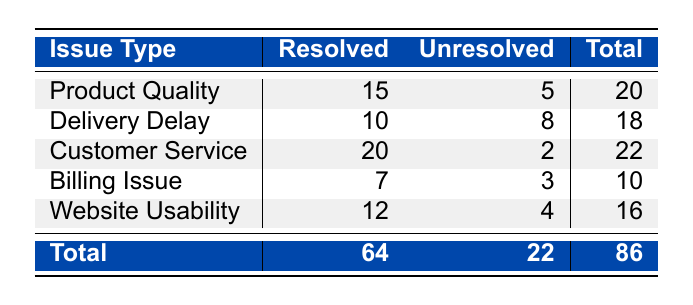What is the total number of unresolved customer complaints? To find the total number of unresolved complaints, I will sum the "Unresolved" counts from each issue type. The values are 5 (Product Quality) + 8 (Delivery Delay) + 2 (Customer Service) + 3 (Billing Issue) + 4 (Website Usability), which equals 22.
Answer: 22 How many complaints were resolved for Customer Service? The table shows that for Customer Service, the "Resolved" count is 20. Therefore, the number of resolved complaints is directly referred to in the table.
Answer: 20 Which issue type has the highest number of unresolved complaints? According to the table, the unresolved counts are: Product Quality (5), Delivery Delay (8), Customer Service (2), Billing Issue (3), and Website Usability (4). The maximum is 8 from Delivery Delay.
Answer: Delivery Delay What is the difference between resolved and unresolved complaints for Product Quality? I will calculate the difference by taking the resolved count (15) and subtracting the unresolved count (5). Therefore, 15 - 5 equals 10, showing that there are 10 more resolved complaints than unresolved for Product Quality.
Answer: 10 Is the total number of resolved complaints greater than the total number of unresolved complaints? By checking the totals, resolved complaints are 64 and unresolved complaints are 22. Since 64 is greater than 22, this statement is true.
Answer: Yes What is the average number of resolved complaints across all issue types? First, I sum the resolved counts: 15 + 10 + 20 + 7 + 12 = 64. Then, I divide by the total number of issue types (5): 64 / 5 = 12.8. Thus, the average resolved complaints per issue type is 12.8.
Answer: 12.8 How many total complaints were received for Billing Issue? The total complaints for Billing Issue can be calculated by adding the resolved (7) and unresolved (3) counts: 7 + 3 equals 10. This shows the total number of complaints for that issue.
Answer: 10 Which issue type has the highest total number of complaints? I will look at the total counts: Product Quality (20), Delivery Delay (18), Customer Service (22), Billing Issue (10), Website Usability (16). The highest total is 22 for Customer Service.
Answer: Customer Service 